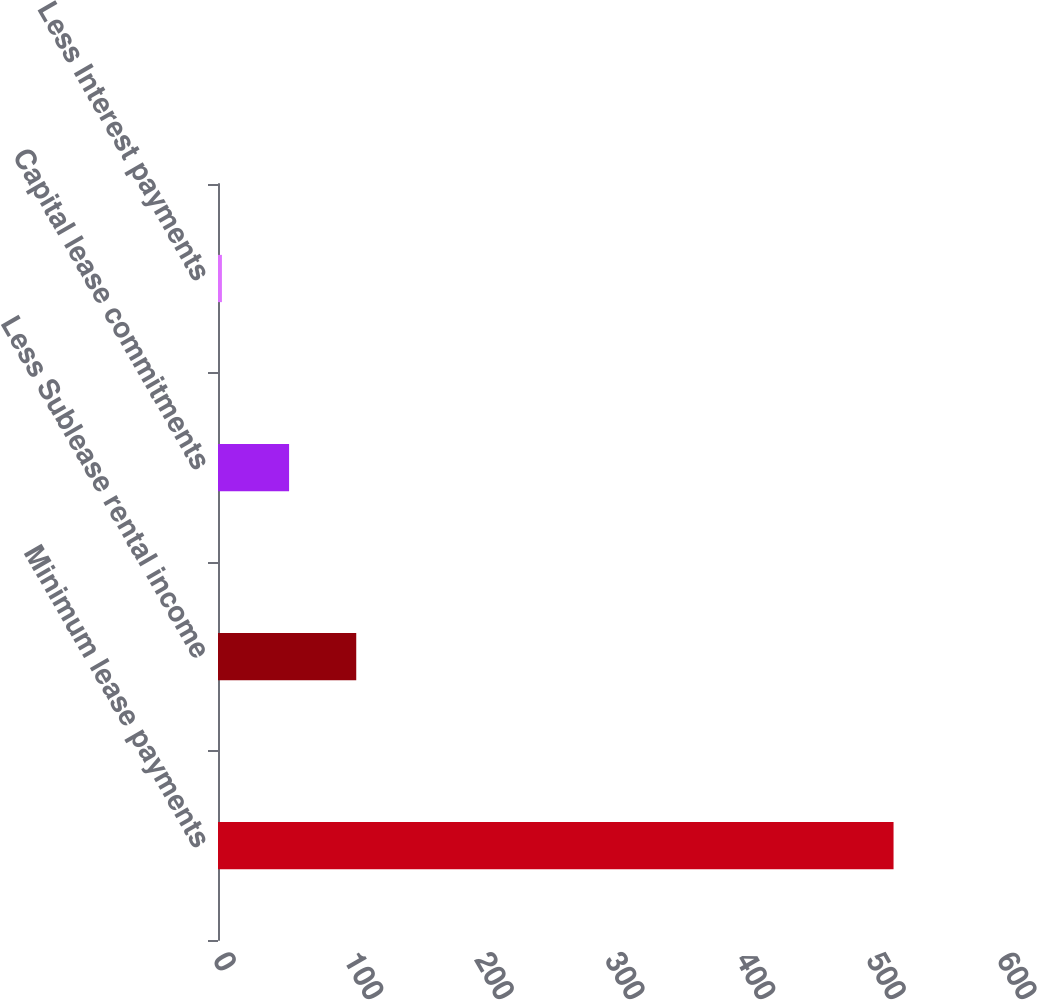Convert chart. <chart><loc_0><loc_0><loc_500><loc_500><bar_chart><fcel>Minimum lease payments<fcel>Less Sublease rental income<fcel>Capital lease commitments<fcel>Less Interest payments<nl><fcel>517<fcel>105.8<fcel>54.4<fcel>3<nl></chart> 